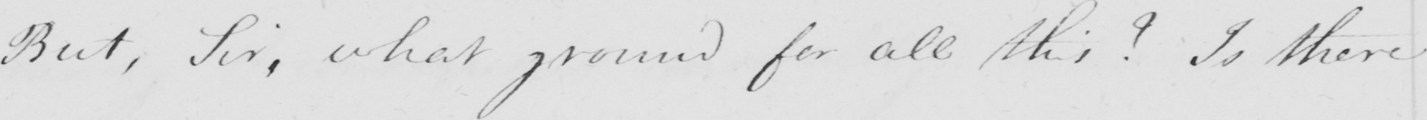Can you tell me what this handwritten text says? But , Sir , what ground for all this ?  Is there 